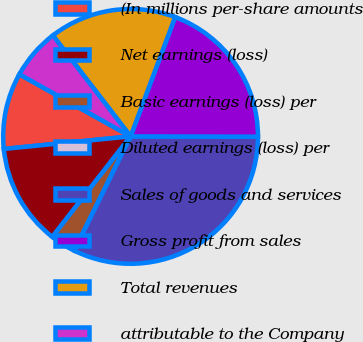Convert chart. <chart><loc_0><loc_0><loc_500><loc_500><pie_chart><fcel>(In millions per-share amounts<fcel>Net earnings (loss)<fcel>Basic earnings (loss) per<fcel>Diluted earnings (loss) per<fcel>Sales of goods and services<fcel>Gross profit from sales<fcel>Total revenues<fcel>attributable to the Company<nl><fcel>9.68%<fcel>12.9%<fcel>3.23%<fcel>0.0%<fcel>32.26%<fcel>19.35%<fcel>16.13%<fcel>6.45%<nl></chart> 